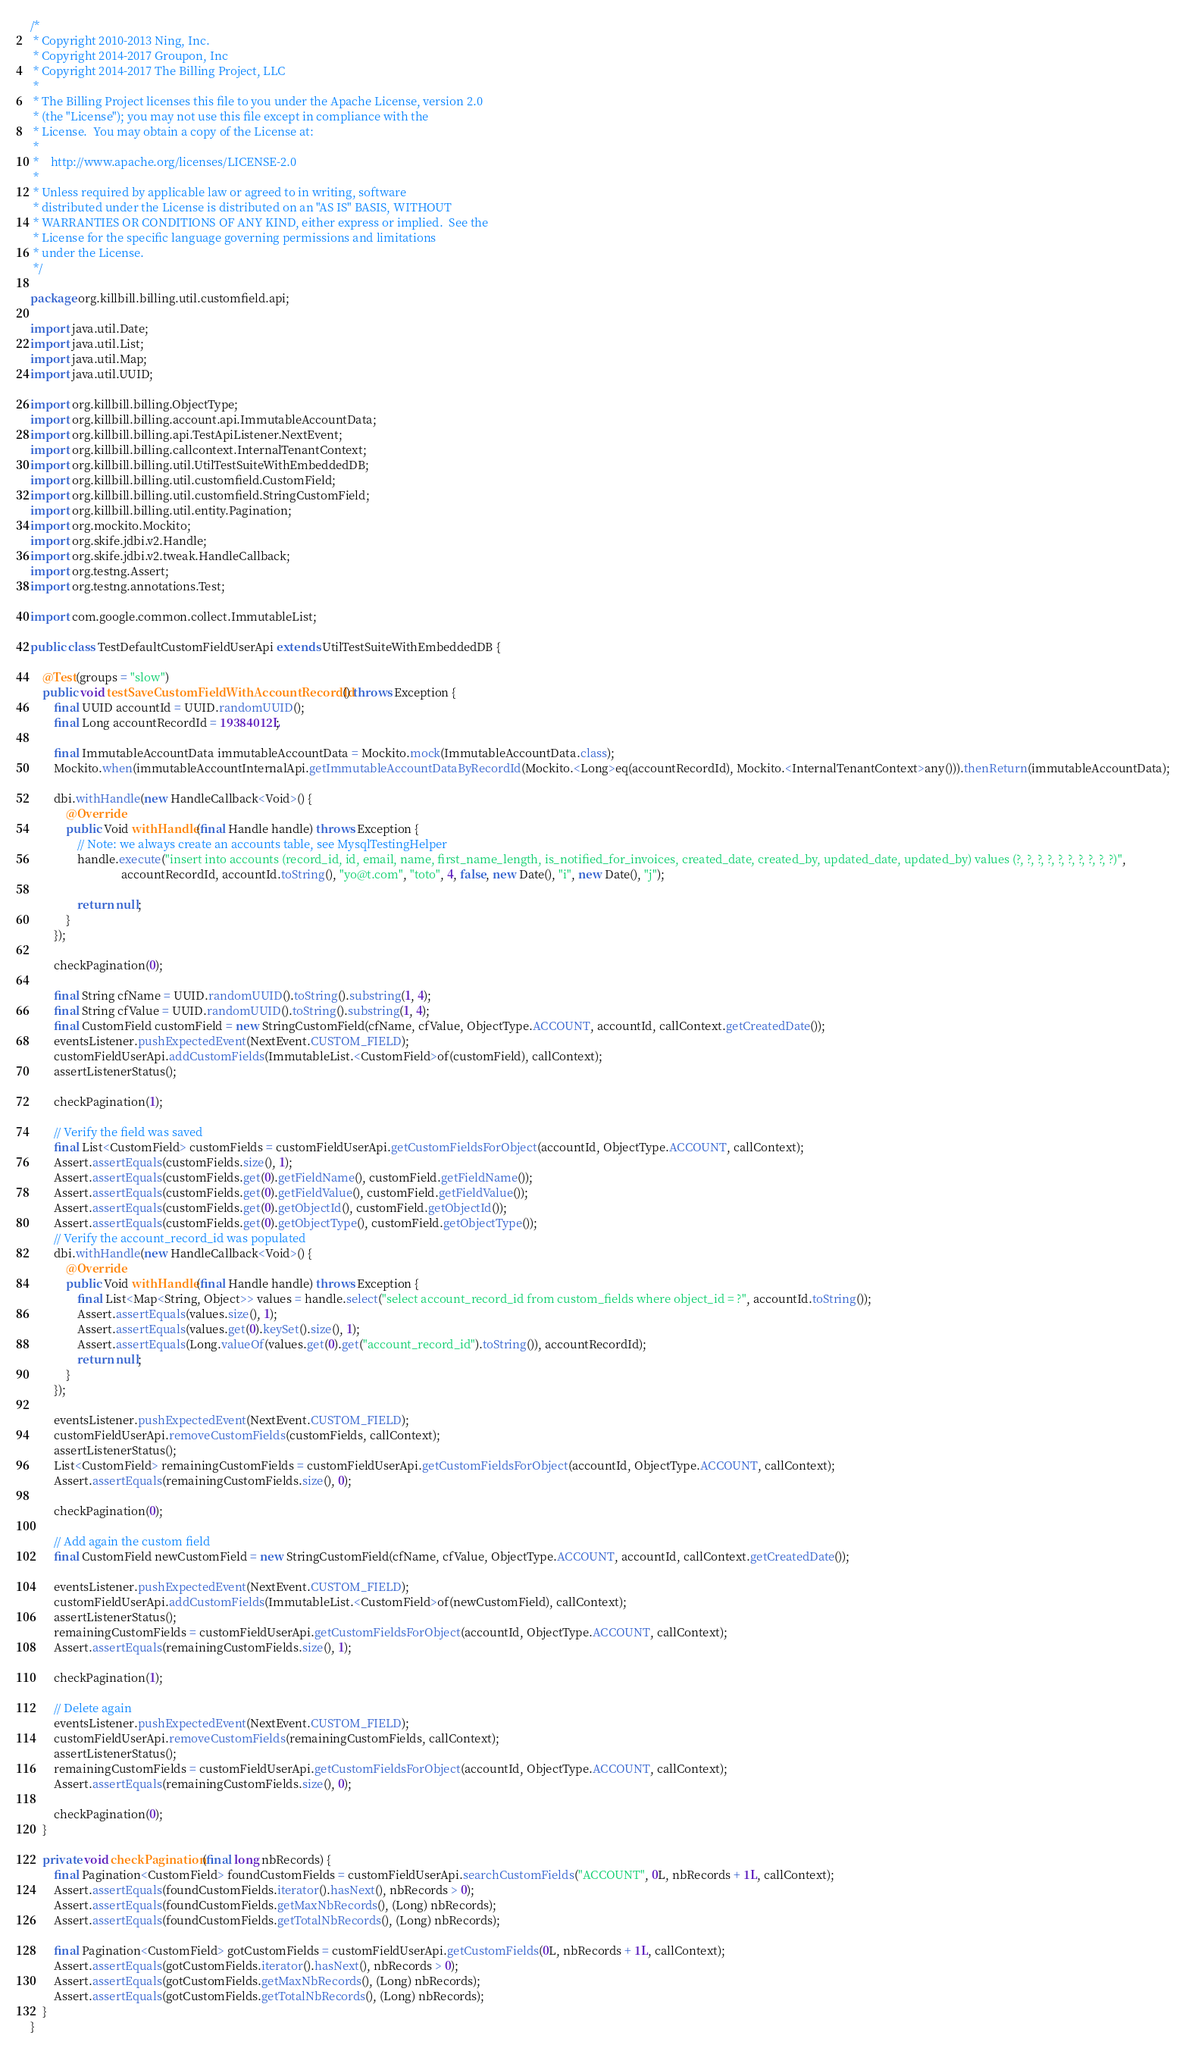<code> <loc_0><loc_0><loc_500><loc_500><_Java_>/*
 * Copyright 2010-2013 Ning, Inc.
 * Copyright 2014-2017 Groupon, Inc
 * Copyright 2014-2017 The Billing Project, LLC
 *
 * The Billing Project licenses this file to you under the Apache License, version 2.0
 * (the "License"); you may not use this file except in compliance with the
 * License.  You may obtain a copy of the License at:
 *
 *    http://www.apache.org/licenses/LICENSE-2.0
 *
 * Unless required by applicable law or agreed to in writing, software
 * distributed under the License is distributed on an "AS IS" BASIS, WITHOUT
 * WARRANTIES OR CONDITIONS OF ANY KIND, either express or implied.  See the
 * License for the specific language governing permissions and limitations
 * under the License.
 */

package org.killbill.billing.util.customfield.api;

import java.util.Date;
import java.util.List;
import java.util.Map;
import java.util.UUID;

import org.killbill.billing.ObjectType;
import org.killbill.billing.account.api.ImmutableAccountData;
import org.killbill.billing.api.TestApiListener.NextEvent;
import org.killbill.billing.callcontext.InternalTenantContext;
import org.killbill.billing.util.UtilTestSuiteWithEmbeddedDB;
import org.killbill.billing.util.customfield.CustomField;
import org.killbill.billing.util.customfield.StringCustomField;
import org.killbill.billing.util.entity.Pagination;
import org.mockito.Mockito;
import org.skife.jdbi.v2.Handle;
import org.skife.jdbi.v2.tweak.HandleCallback;
import org.testng.Assert;
import org.testng.annotations.Test;

import com.google.common.collect.ImmutableList;

public class TestDefaultCustomFieldUserApi extends UtilTestSuiteWithEmbeddedDB {

    @Test(groups = "slow")
    public void testSaveCustomFieldWithAccountRecordId() throws Exception {
        final UUID accountId = UUID.randomUUID();
        final Long accountRecordId = 19384012L;

        final ImmutableAccountData immutableAccountData = Mockito.mock(ImmutableAccountData.class);
        Mockito.when(immutableAccountInternalApi.getImmutableAccountDataByRecordId(Mockito.<Long>eq(accountRecordId), Mockito.<InternalTenantContext>any())).thenReturn(immutableAccountData);

        dbi.withHandle(new HandleCallback<Void>() {
            @Override
            public Void withHandle(final Handle handle) throws Exception {
                // Note: we always create an accounts table, see MysqlTestingHelper
                handle.execute("insert into accounts (record_id, id, email, name, first_name_length, is_notified_for_invoices, created_date, created_by, updated_date, updated_by) values (?, ?, ?, ?, ?, ?, ?, ?, ?, ?)",
                               accountRecordId, accountId.toString(), "yo@t.com", "toto", 4, false, new Date(), "i", new Date(), "j");

                return null;
            }
        });

        checkPagination(0);

        final String cfName = UUID.randomUUID().toString().substring(1, 4);
        final String cfValue = UUID.randomUUID().toString().substring(1, 4);
        final CustomField customField = new StringCustomField(cfName, cfValue, ObjectType.ACCOUNT, accountId, callContext.getCreatedDate());
        eventsListener.pushExpectedEvent(NextEvent.CUSTOM_FIELD);
        customFieldUserApi.addCustomFields(ImmutableList.<CustomField>of(customField), callContext);
        assertListenerStatus();

        checkPagination(1);

        // Verify the field was saved
        final List<CustomField> customFields = customFieldUserApi.getCustomFieldsForObject(accountId, ObjectType.ACCOUNT, callContext);
        Assert.assertEquals(customFields.size(), 1);
        Assert.assertEquals(customFields.get(0).getFieldName(), customField.getFieldName());
        Assert.assertEquals(customFields.get(0).getFieldValue(), customField.getFieldValue());
        Assert.assertEquals(customFields.get(0).getObjectId(), customField.getObjectId());
        Assert.assertEquals(customFields.get(0).getObjectType(), customField.getObjectType());
        // Verify the account_record_id was populated
        dbi.withHandle(new HandleCallback<Void>() {
            @Override
            public Void withHandle(final Handle handle) throws Exception {
                final List<Map<String, Object>> values = handle.select("select account_record_id from custom_fields where object_id = ?", accountId.toString());
                Assert.assertEquals(values.size(), 1);
                Assert.assertEquals(values.get(0).keySet().size(), 1);
                Assert.assertEquals(Long.valueOf(values.get(0).get("account_record_id").toString()), accountRecordId);
                return null;
            }
        });

        eventsListener.pushExpectedEvent(NextEvent.CUSTOM_FIELD);
        customFieldUserApi.removeCustomFields(customFields, callContext);
        assertListenerStatus();
        List<CustomField> remainingCustomFields = customFieldUserApi.getCustomFieldsForObject(accountId, ObjectType.ACCOUNT, callContext);
        Assert.assertEquals(remainingCustomFields.size(), 0);

        checkPagination(0);

        // Add again the custom field
        final CustomField newCustomField = new StringCustomField(cfName, cfValue, ObjectType.ACCOUNT, accountId, callContext.getCreatedDate());

        eventsListener.pushExpectedEvent(NextEvent.CUSTOM_FIELD);
        customFieldUserApi.addCustomFields(ImmutableList.<CustomField>of(newCustomField), callContext);
        assertListenerStatus();
        remainingCustomFields = customFieldUserApi.getCustomFieldsForObject(accountId, ObjectType.ACCOUNT, callContext);
        Assert.assertEquals(remainingCustomFields.size(), 1);

        checkPagination(1);

        // Delete again
        eventsListener.pushExpectedEvent(NextEvent.CUSTOM_FIELD);
        customFieldUserApi.removeCustomFields(remainingCustomFields, callContext);
        assertListenerStatus();
        remainingCustomFields = customFieldUserApi.getCustomFieldsForObject(accountId, ObjectType.ACCOUNT, callContext);
        Assert.assertEquals(remainingCustomFields.size(), 0);

        checkPagination(0);
    }

    private void checkPagination(final long nbRecords) {
        final Pagination<CustomField> foundCustomFields = customFieldUserApi.searchCustomFields("ACCOUNT", 0L, nbRecords + 1L, callContext);
        Assert.assertEquals(foundCustomFields.iterator().hasNext(), nbRecords > 0);
        Assert.assertEquals(foundCustomFields.getMaxNbRecords(), (Long) nbRecords);
        Assert.assertEquals(foundCustomFields.getTotalNbRecords(), (Long) nbRecords);

        final Pagination<CustomField> gotCustomFields = customFieldUserApi.getCustomFields(0L, nbRecords + 1L, callContext);
        Assert.assertEquals(gotCustomFields.iterator().hasNext(), nbRecords > 0);
        Assert.assertEquals(gotCustomFields.getMaxNbRecords(), (Long) nbRecords);
        Assert.assertEquals(gotCustomFields.getTotalNbRecords(), (Long) nbRecords);
    }
}
</code> 